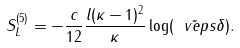Convert formula to latex. <formula><loc_0><loc_0><loc_500><loc_500>S _ { L } ^ { ( 5 ) } = - \frac { c } { 1 2 } \frac { l ( \kappa - 1 ) ^ { 2 } } { \kappa } \log ( \tilde { \ v e p s } \delta ) .</formula> 